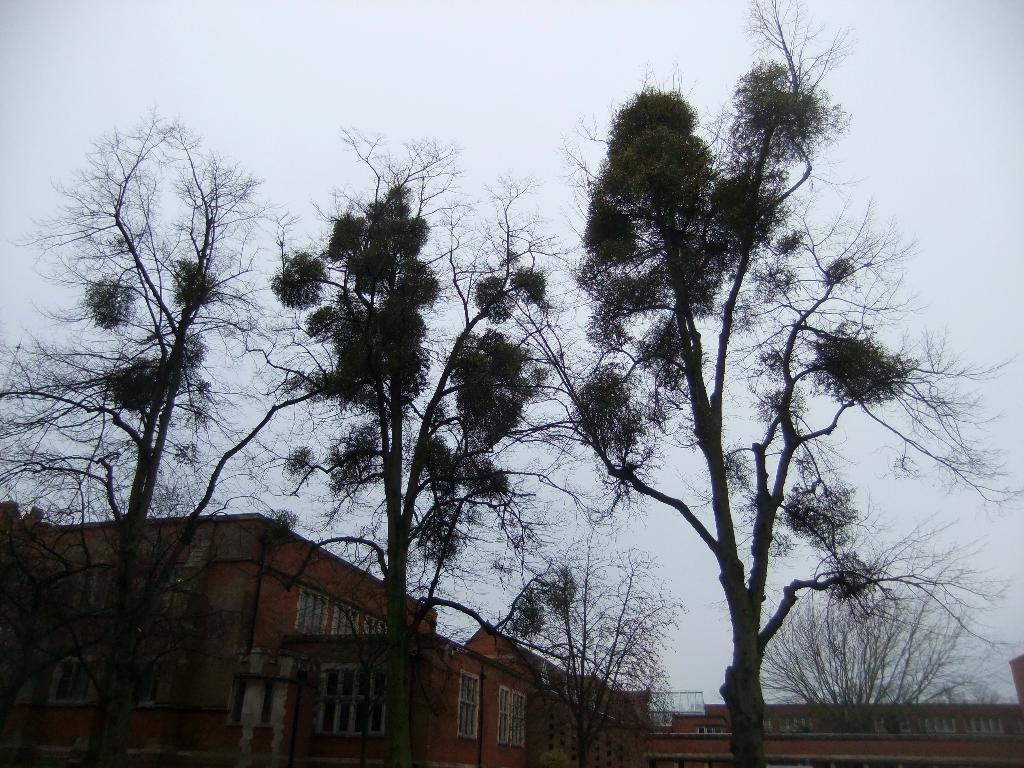What type of structures can be seen in the image? There are buildings in the image. What other natural elements are present in the image? Trees are present in the image. What is visible at the top of the image? The sky is visible at the top of the image. What feature can be seen on the buildings in the image? There are windows visible in the image. Where is the store located in the image? There is no store present in the image. Can you see a yak grazing in the image? There is no yak present in the image. 